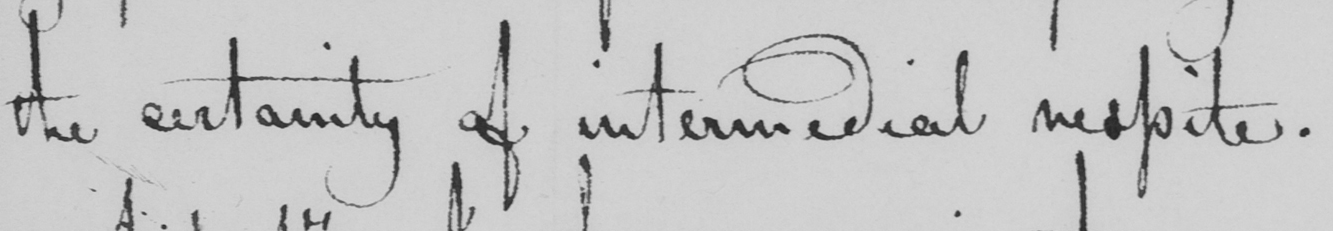What does this handwritten line say? the certainty of intermedial respite . 